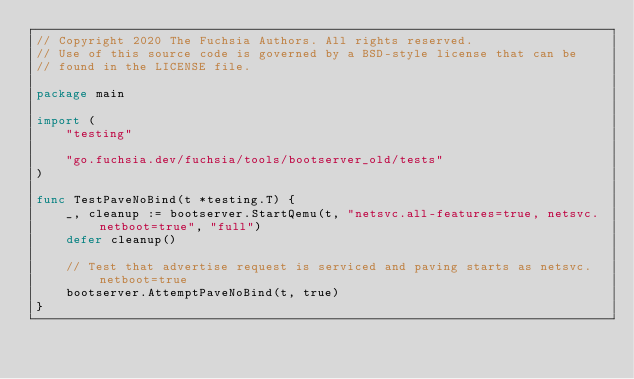<code> <loc_0><loc_0><loc_500><loc_500><_Go_>// Copyright 2020 The Fuchsia Authors. All rights reserved.
// Use of this source code is governed by a BSD-style license that can be
// found in the LICENSE file.

package main

import (
	"testing"

	"go.fuchsia.dev/fuchsia/tools/bootserver_old/tests"
)

func TestPaveNoBind(t *testing.T) {
	_, cleanup := bootserver.StartQemu(t, "netsvc.all-features=true, netsvc.netboot=true", "full")
	defer cleanup()

	// Test that advertise request is serviced and paving starts as netsvc.netboot=true
	bootserver.AttemptPaveNoBind(t, true)
}
</code> 